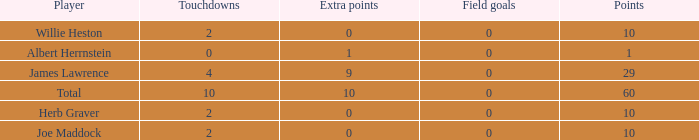What is the smallest number of field goals for players with 4 touchdowns and less than 9 extra points? None. 